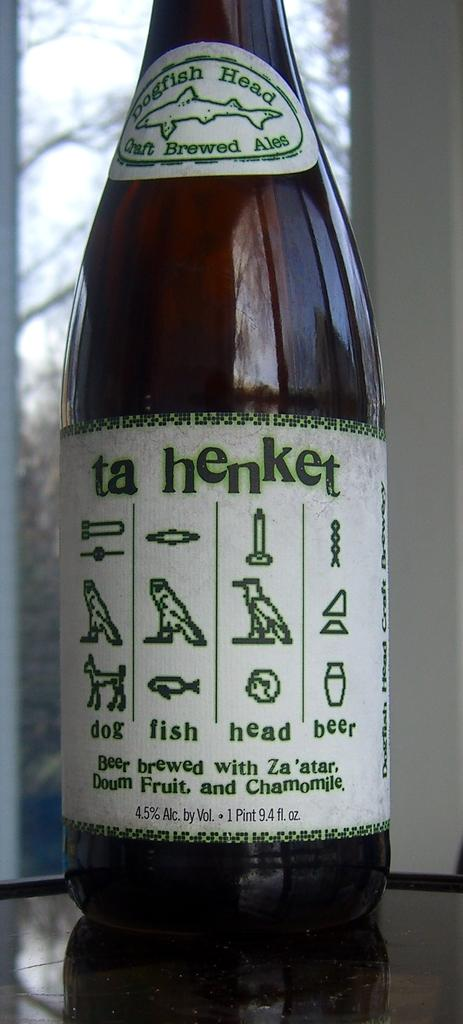<image>
Present a compact description of the photo's key features. a bottle of ta henket by dogfish head beer 